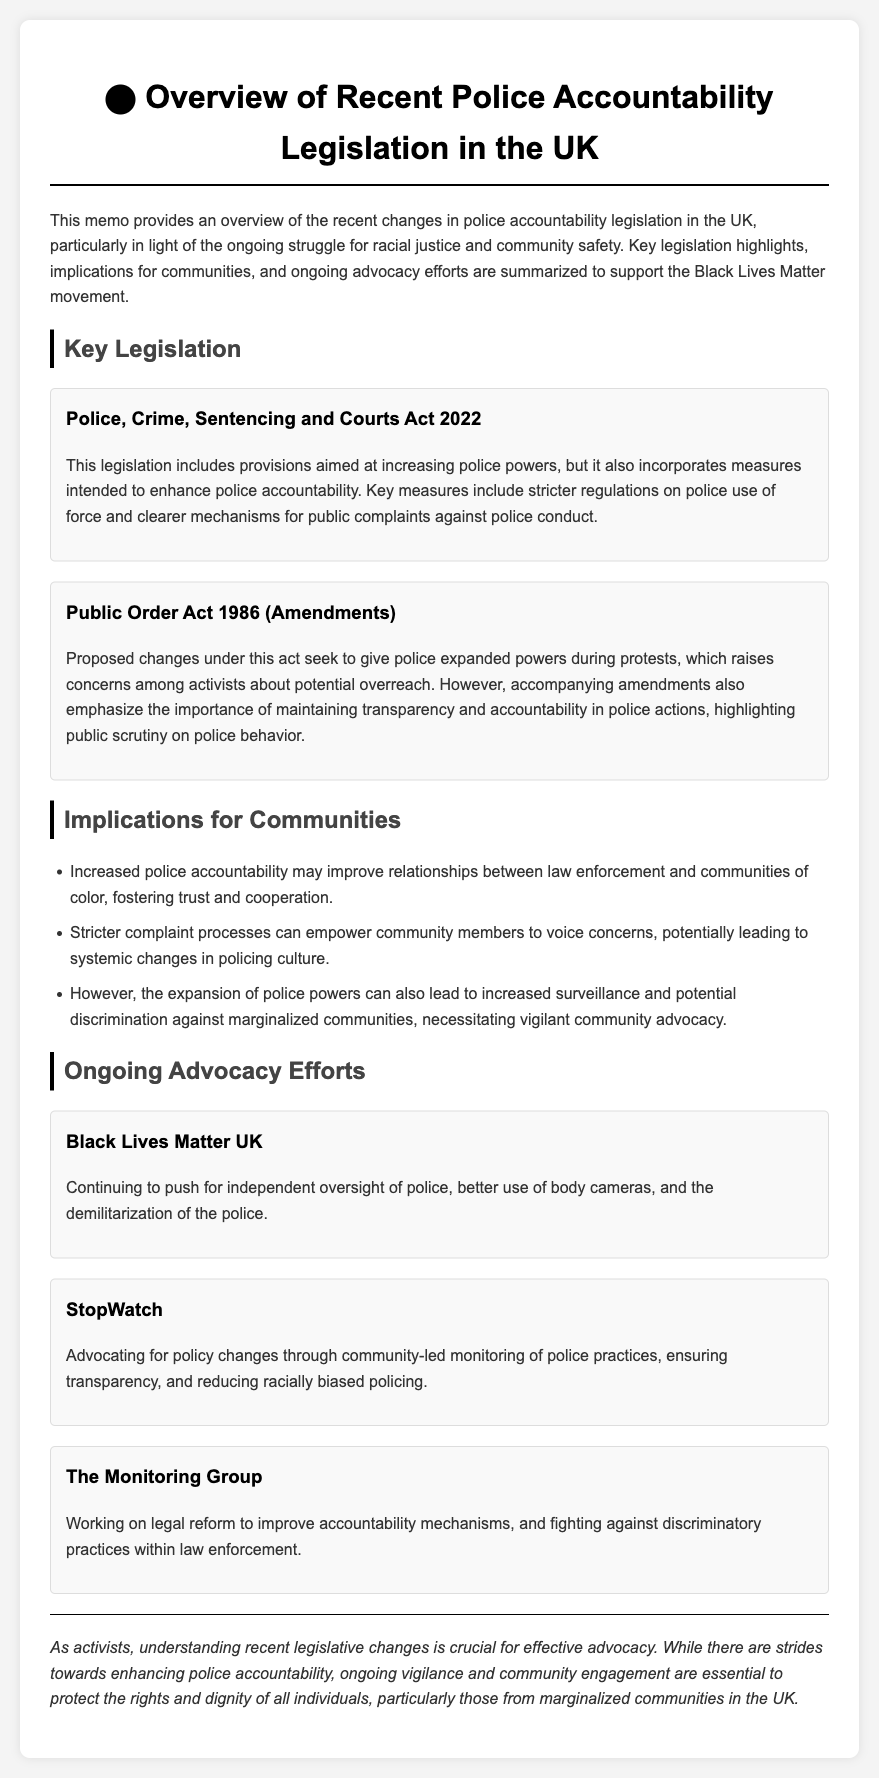What is the title of the legislation that includes measures for police accountability? The title of the legislation that includes measures for police accountability is stated in the document as "Police, Crime, Sentencing and Courts Act 2022."
Answer: Police, Crime, Sentencing and Courts Act 2022 What is one key provision included in the Police, Crime, Sentencing and Courts Act 2022? The document mentions that one key provision includes "stricter regulations on police use of force."
Answer: Stricter regulations on police use of force Which organization advocates for independent oversight of police? The document lists "Black Lives Matter UK" as the organization advocating for independent oversight of police.
Answer: Black Lives Matter UK What is a potential consequence of the expanded police powers according to the document? The document highlights one consequence as "increased surveillance and potential discrimination against marginalized communities."
Answer: Increased surveillance and potential discrimination What is the main focus of StopWatch as discussed in the memo? The memo indicates that StopWatch focuses on "community-led monitoring of police practices."
Answer: Community-led monitoring of police practices What does the conclusion emphasize about community engagement? The conclusion emphasizes the importance of "ongoing vigilance and community engagement."
Answer: Ongoing vigilance and community engagement What legal reform is The Monitoring Group working on? The document states that The Monitoring Group is working on "legal reform to improve accountability mechanisms."
Answer: Legal reform to improve accountability mechanisms What does the Public Order Act 1986 (Amendments) seek to do? The document explains that the amendments seek to "give police expanded powers during protests."
Answer: Give police expanded powers during protests 